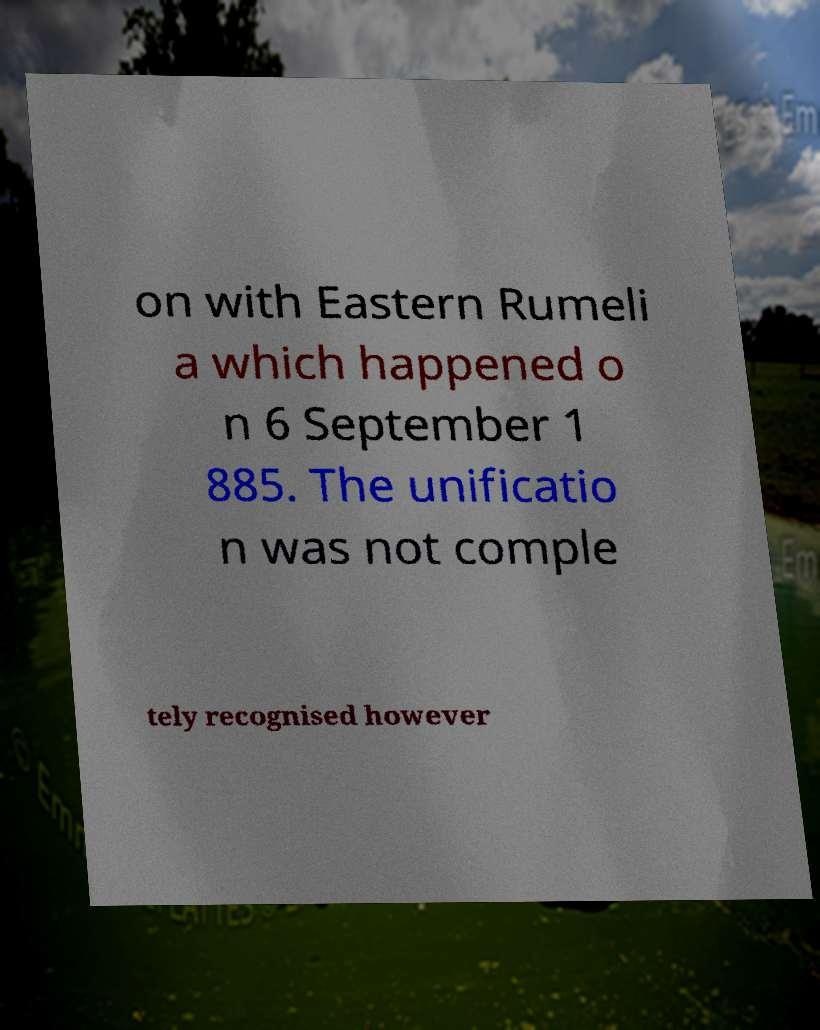Please identify and transcribe the text found in this image. on with Eastern Rumeli a which happened o n 6 September 1 885. The unificatio n was not comple tely recognised however 